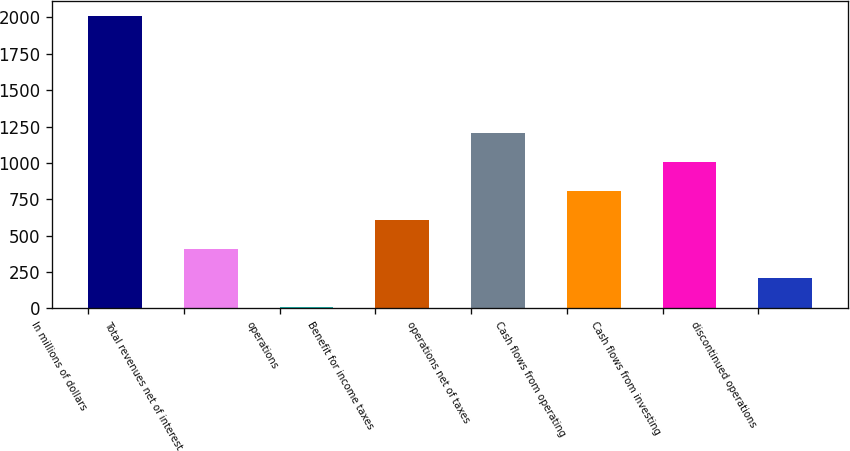Convert chart to OTSL. <chart><loc_0><loc_0><loc_500><loc_500><bar_chart><fcel>In millions of dollars<fcel>Total revenues net of interest<fcel>operations<fcel>Benefit for income taxes<fcel>operations net of taxes<fcel>Cash flows from operating<fcel>Cash flows from investing<fcel>discontinued operations<nl><fcel>2010<fcel>407.6<fcel>7<fcel>607.9<fcel>1208.8<fcel>808.2<fcel>1008.5<fcel>207.3<nl></chart> 